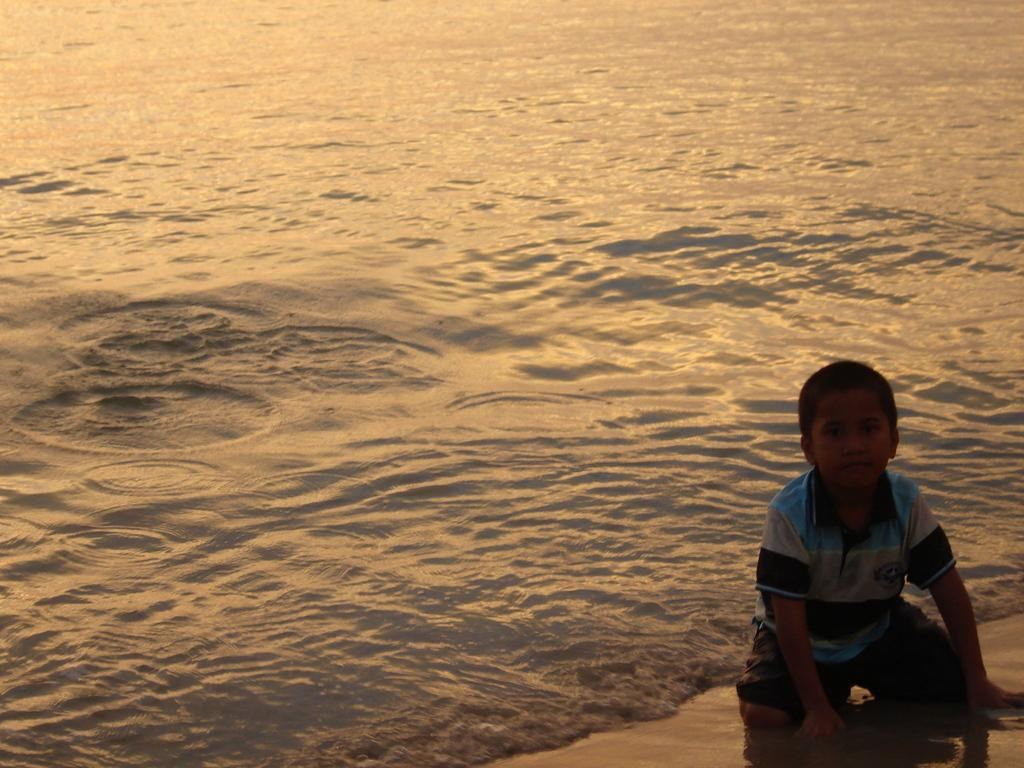Who is the main subject in the image? There is a boy in the image. What position is the boy in? The boy is in a crouch position. Where is the boy located? The boy is on the sand, which is at the water. On which side of the image is the boy? The boy is on the right side of the image. What type of guitar is the boy playing in the image? There is no guitar present in the image; the boy is in a crouch position on the sand. 